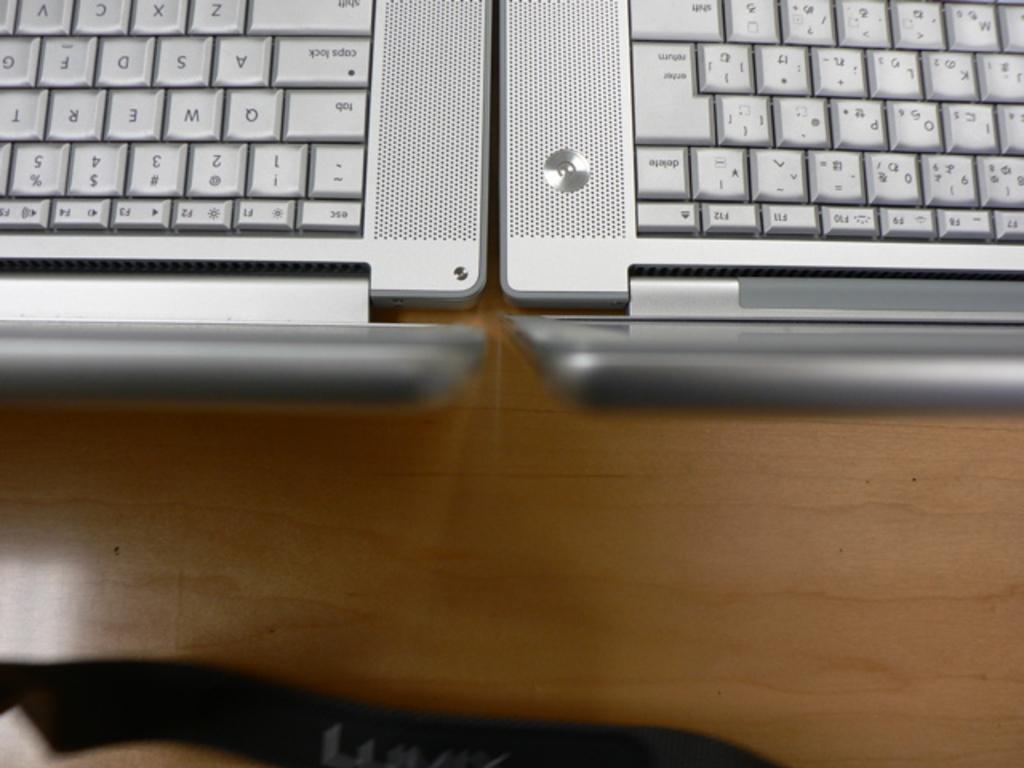How would you summarize this image in a sentence or two? In this picture we can see keyboards. 